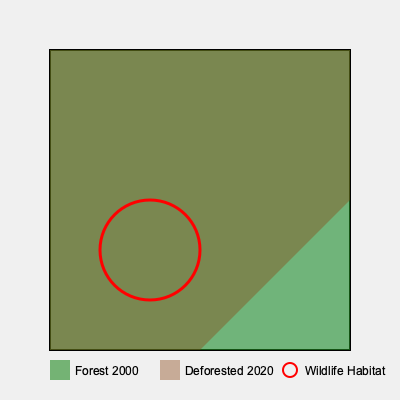Based on the layered map showing deforestation from 2000 to 2020, what percentage of the highlighted wildlife habitat area has been affected by deforestation? To determine the percentage of the wildlife habitat affected by deforestation, we need to follow these steps:

1. Identify the wildlife habitat area, represented by the red circle.
2. Observe the forest cover in 2000 (green layer) and the deforested area in 2020 (brown layer).
3. Estimate the portion of the wildlife habitat circle that overlaps with the deforested area.
4. Calculate the percentage of the habitat affected.

Looking at the map:
1. The wildlife habitat is represented by a red circle in the lower-left quadrant.
2. The entire map was forested in 2000 (green layer).
3. By 2020, deforestation (brown layer) has occurred in the upper-right portion of the map.
4. The deforestation layer covers approximately half of the wildlife habitat circle.

Since the deforested area covers about half of the wildlife habitat circle, we can estimate that approximately 50% of the habitat has been affected by deforestation between 2000 and 2020.

This visual analysis demonstrates the significant impact of deforestation on wildlife habitats over a 20-year period, highlighting the urgent need for conservation efforts and stricter regulations to protect these crucial ecosystems.
Answer: 50% 